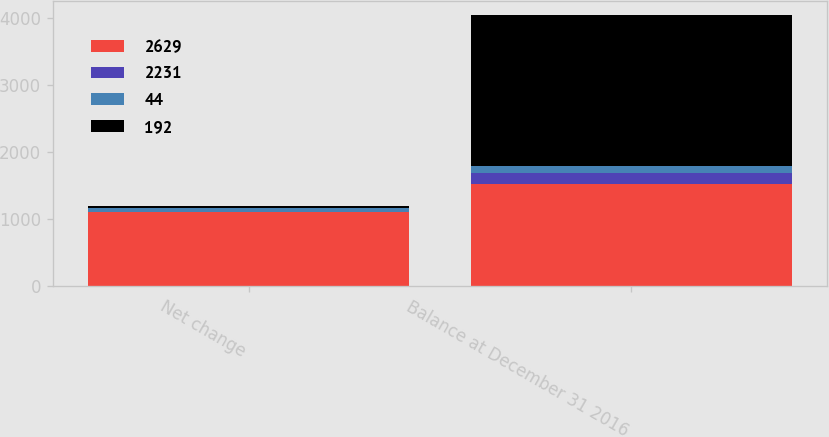<chart> <loc_0><loc_0><loc_500><loc_500><stacked_bar_chart><ecel><fcel>Net change<fcel>Balance at December 31 2016<nl><fcel>2629<fcel>1105<fcel>1524<nl><fcel>2231<fcel>2<fcel>164<nl><fcel>44<fcel>56<fcel>100<nl><fcel>192<fcel>28<fcel>2259<nl></chart> 